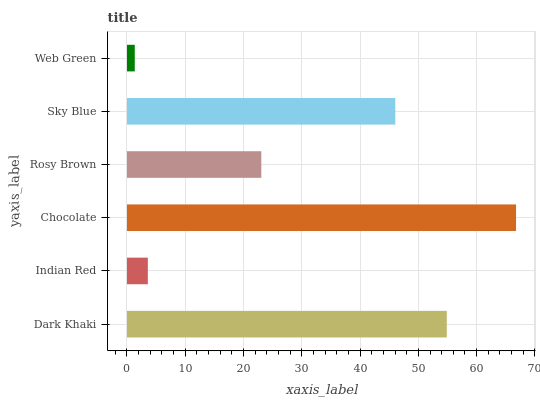Is Web Green the minimum?
Answer yes or no. Yes. Is Chocolate the maximum?
Answer yes or no. Yes. Is Indian Red the minimum?
Answer yes or no. No. Is Indian Red the maximum?
Answer yes or no. No. Is Dark Khaki greater than Indian Red?
Answer yes or no. Yes. Is Indian Red less than Dark Khaki?
Answer yes or no. Yes. Is Indian Red greater than Dark Khaki?
Answer yes or no. No. Is Dark Khaki less than Indian Red?
Answer yes or no. No. Is Sky Blue the high median?
Answer yes or no. Yes. Is Rosy Brown the low median?
Answer yes or no. Yes. Is Web Green the high median?
Answer yes or no. No. Is Indian Red the low median?
Answer yes or no. No. 